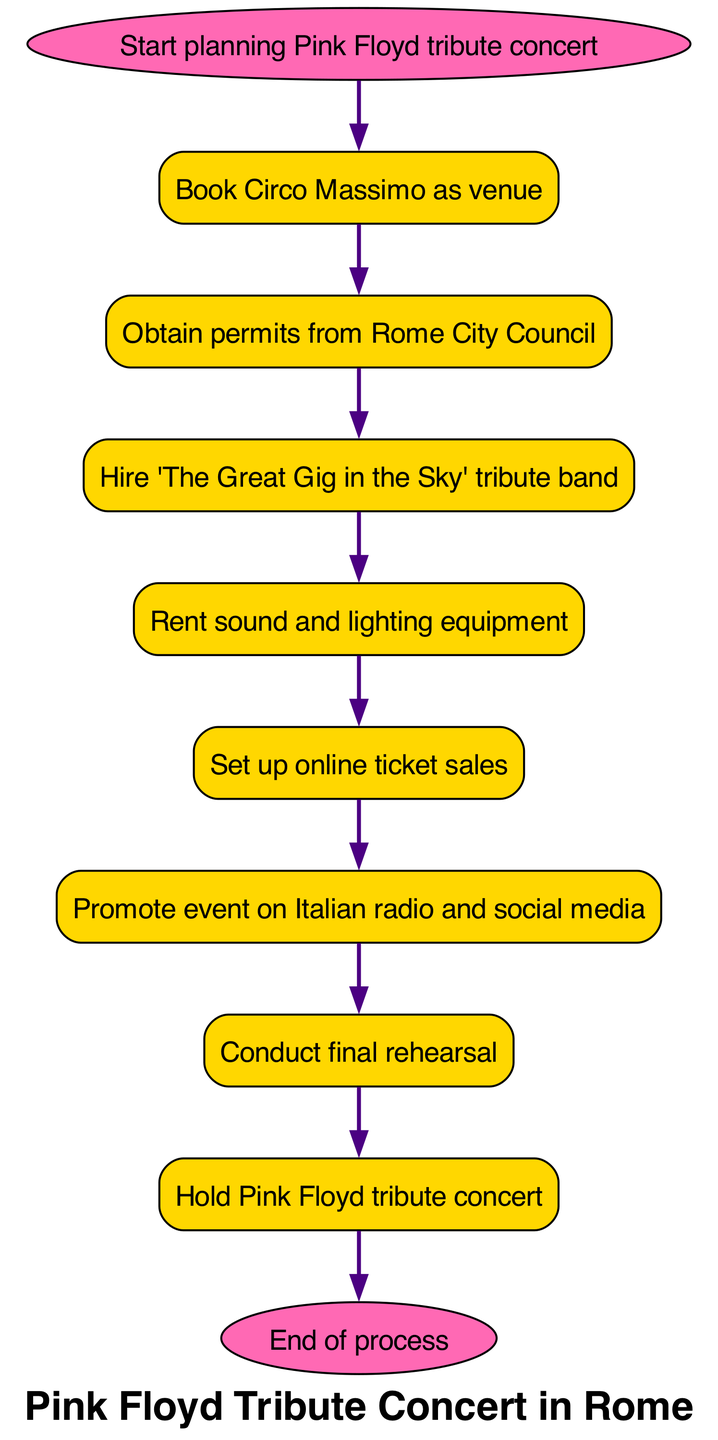What is the first step in organizing the concert? The first node in the flowchart is labeled "Start planning Pink Floyd tribute concert," which indicates the initiation of the concert organization process.
Answer: Start planning Pink Floyd tribute concert How many nodes are present in the diagram? The diagram lists a total of 10 nodes, each representing a specific step in the concert organization process, from start to end.
Answer: 10 What is the last step before the concert is held? The final step before the concert, as indicated in the flowchart, is "Conduct final rehearsal," which takes place just prior to the actual event.
Answer: Conduct final rehearsal Which band is hired for the tribute concert? The flowchart specifies the hire of "The Great Gig in the Sky" tribute band, which is the official act for the concert.
Answer: The Great Gig in the Sky What needs to be obtained after booking the venue? Following the booking of the venue at Circo Massimo, the next necessary step is to "Obtain permits from Rome City Council" to legitimize the event.
Answer: Obtain permits from Rome City Council Which action follows setting up online ticket sales? After setting up online ticket sales, the next action in the sequence is to "Promote event on Italian radio and social media," which is crucial for attracting attendees.
Answer: Promote event on Italian radio and social media How many edges connect the nodes in the diagram? The diagram contains 9 edges, which represent the directional connections between nodes, indicating the flow from one action to the next throughout the concert organization.
Answer: 9 What is the shape of the start and end nodes? The start and end nodes are designed as ellipses, which are distinct from the rectangular shapes used for the other steps in the flowchart, signifying the beginning and conclusion of the process.
Answer: ellipse What is the primary venue chosen for the concert? "Circo Massimo" is identified as the primary venue in the second node of the flowchart, highlighting its significance for hosting the tribute concert.
Answer: Circo Massimo Which step involves final preparations before the event? The step that involves final preparations before the event is "Conduct final rehearsal," which ensures the band is ready and all arrangements are in place for the concert.
Answer: Conduct final rehearsal 